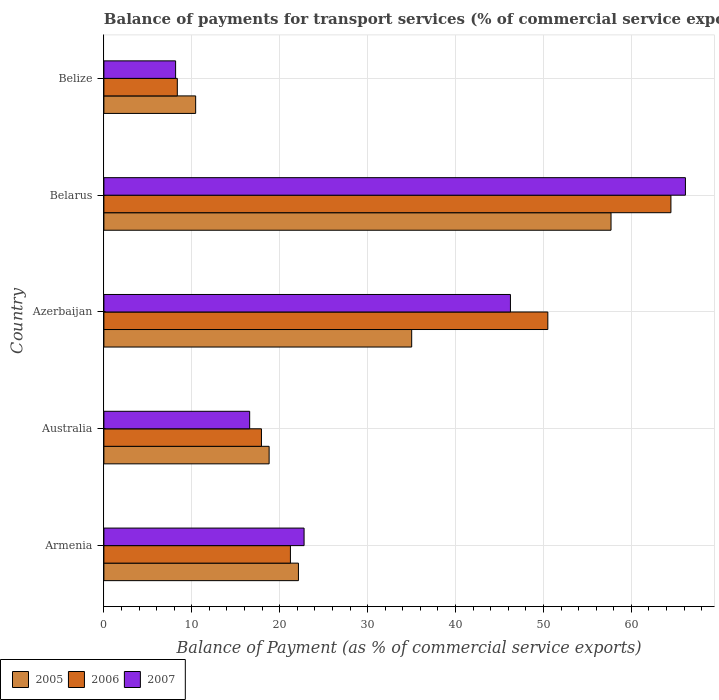How many different coloured bars are there?
Ensure brevity in your answer.  3. Are the number of bars on each tick of the Y-axis equal?
Offer a terse response. Yes. How many bars are there on the 2nd tick from the top?
Ensure brevity in your answer.  3. What is the label of the 2nd group of bars from the top?
Offer a terse response. Belarus. In how many cases, is the number of bars for a given country not equal to the number of legend labels?
Ensure brevity in your answer.  0. What is the balance of payments for transport services in 2005 in Azerbaijan?
Your answer should be compact. 35.01. Across all countries, what is the maximum balance of payments for transport services in 2007?
Make the answer very short. 66.15. Across all countries, what is the minimum balance of payments for transport services in 2006?
Provide a succinct answer. 8.35. In which country was the balance of payments for transport services in 2006 maximum?
Offer a terse response. Belarus. In which country was the balance of payments for transport services in 2007 minimum?
Provide a succinct answer. Belize. What is the total balance of payments for transport services in 2007 in the graph?
Your answer should be compact. 159.92. What is the difference between the balance of payments for transport services in 2007 in Armenia and that in Belize?
Provide a short and direct response. 14.61. What is the difference between the balance of payments for transport services in 2005 in Belarus and the balance of payments for transport services in 2007 in Armenia?
Offer a very short reply. 34.92. What is the average balance of payments for transport services in 2005 per country?
Your answer should be compact. 28.81. What is the difference between the balance of payments for transport services in 2007 and balance of payments for transport services in 2005 in Azerbaijan?
Your answer should be compact. 11.23. What is the ratio of the balance of payments for transport services in 2007 in Armenia to that in Azerbaijan?
Your response must be concise. 0.49. Is the balance of payments for transport services in 2006 in Australia less than that in Belize?
Provide a short and direct response. No. What is the difference between the highest and the second highest balance of payments for transport services in 2007?
Your answer should be compact. 19.91. What is the difference between the highest and the lowest balance of payments for transport services in 2007?
Ensure brevity in your answer.  58. In how many countries, is the balance of payments for transport services in 2006 greater than the average balance of payments for transport services in 2006 taken over all countries?
Provide a succinct answer. 2. What does the 3rd bar from the bottom in Azerbaijan represents?
Ensure brevity in your answer.  2007. Are all the bars in the graph horizontal?
Your answer should be very brief. Yes. How many countries are there in the graph?
Offer a very short reply. 5. What is the difference between two consecutive major ticks on the X-axis?
Provide a short and direct response. 10. Are the values on the major ticks of X-axis written in scientific E-notation?
Give a very brief answer. No. Does the graph contain any zero values?
Offer a very short reply. No. Does the graph contain grids?
Keep it short and to the point. Yes. Where does the legend appear in the graph?
Provide a succinct answer. Bottom left. How are the legend labels stacked?
Offer a terse response. Horizontal. What is the title of the graph?
Offer a very short reply. Balance of payments for transport services (% of commercial service exports). What is the label or title of the X-axis?
Provide a succinct answer. Balance of Payment (as % of commercial service exports). What is the Balance of Payment (as % of commercial service exports) in 2005 in Armenia?
Your response must be concise. 22.13. What is the Balance of Payment (as % of commercial service exports) in 2006 in Armenia?
Offer a very short reply. 21.22. What is the Balance of Payment (as % of commercial service exports) in 2007 in Armenia?
Provide a succinct answer. 22.77. What is the Balance of Payment (as % of commercial service exports) of 2005 in Australia?
Keep it short and to the point. 18.8. What is the Balance of Payment (as % of commercial service exports) in 2006 in Australia?
Provide a short and direct response. 17.92. What is the Balance of Payment (as % of commercial service exports) of 2007 in Australia?
Offer a terse response. 16.58. What is the Balance of Payment (as % of commercial service exports) of 2005 in Azerbaijan?
Keep it short and to the point. 35.01. What is the Balance of Payment (as % of commercial service exports) in 2006 in Azerbaijan?
Provide a succinct answer. 50.5. What is the Balance of Payment (as % of commercial service exports) of 2007 in Azerbaijan?
Your answer should be very brief. 46.25. What is the Balance of Payment (as % of commercial service exports) in 2005 in Belarus?
Ensure brevity in your answer.  57.69. What is the Balance of Payment (as % of commercial service exports) of 2006 in Belarus?
Provide a succinct answer. 64.51. What is the Balance of Payment (as % of commercial service exports) in 2007 in Belarus?
Ensure brevity in your answer.  66.15. What is the Balance of Payment (as % of commercial service exports) of 2005 in Belize?
Provide a succinct answer. 10.44. What is the Balance of Payment (as % of commercial service exports) of 2006 in Belize?
Provide a short and direct response. 8.35. What is the Balance of Payment (as % of commercial service exports) in 2007 in Belize?
Ensure brevity in your answer.  8.16. Across all countries, what is the maximum Balance of Payment (as % of commercial service exports) of 2005?
Provide a succinct answer. 57.69. Across all countries, what is the maximum Balance of Payment (as % of commercial service exports) in 2006?
Offer a terse response. 64.51. Across all countries, what is the maximum Balance of Payment (as % of commercial service exports) in 2007?
Keep it short and to the point. 66.15. Across all countries, what is the minimum Balance of Payment (as % of commercial service exports) of 2005?
Offer a very short reply. 10.44. Across all countries, what is the minimum Balance of Payment (as % of commercial service exports) in 2006?
Your answer should be compact. 8.35. Across all countries, what is the minimum Balance of Payment (as % of commercial service exports) in 2007?
Your response must be concise. 8.16. What is the total Balance of Payment (as % of commercial service exports) in 2005 in the graph?
Your answer should be compact. 144.07. What is the total Balance of Payment (as % of commercial service exports) in 2006 in the graph?
Offer a very short reply. 162.5. What is the total Balance of Payment (as % of commercial service exports) in 2007 in the graph?
Provide a succinct answer. 159.92. What is the difference between the Balance of Payment (as % of commercial service exports) in 2005 in Armenia and that in Australia?
Make the answer very short. 3.33. What is the difference between the Balance of Payment (as % of commercial service exports) in 2006 in Armenia and that in Australia?
Your response must be concise. 3.3. What is the difference between the Balance of Payment (as % of commercial service exports) of 2007 in Armenia and that in Australia?
Your response must be concise. 6.19. What is the difference between the Balance of Payment (as % of commercial service exports) of 2005 in Armenia and that in Azerbaijan?
Offer a very short reply. -12.88. What is the difference between the Balance of Payment (as % of commercial service exports) in 2006 in Armenia and that in Azerbaijan?
Your response must be concise. -29.28. What is the difference between the Balance of Payment (as % of commercial service exports) of 2007 in Armenia and that in Azerbaijan?
Provide a succinct answer. -23.48. What is the difference between the Balance of Payment (as % of commercial service exports) in 2005 in Armenia and that in Belarus?
Ensure brevity in your answer.  -35.56. What is the difference between the Balance of Payment (as % of commercial service exports) in 2006 in Armenia and that in Belarus?
Give a very brief answer. -43.29. What is the difference between the Balance of Payment (as % of commercial service exports) of 2007 in Armenia and that in Belarus?
Your answer should be compact. -43.38. What is the difference between the Balance of Payment (as % of commercial service exports) of 2005 in Armenia and that in Belize?
Give a very brief answer. 11.69. What is the difference between the Balance of Payment (as % of commercial service exports) in 2006 in Armenia and that in Belize?
Make the answer very short. 12.87. What is the difference between the Balance of Payment (as % of commercial service exports) of 2007 in Armenia and that in Belize?
Your response must be concise. 14.61. What is the difference between the Balance of Payment (as % of commercial service exports) in 2005 in Australia and that in Azerbaijan?
Provide a short and direct response. -16.22. What is the difference between the Balance of Payment (as % of commercial service exports) of 2006 in Australia and that in Azerbaijan?
Provide a succinct answer. -32.58. What is the difference between the Balance of Payment (as % of commercial service exports) in 2007 in Australia and that in Azerbaijan?
Your answer should be very brief. -29.66. What is the difference between the Balance of Payment (as % of commercial service exports) of 2005 in Australia and that in Belarus?
Offer a very short reply. -38.89. What is the difference between the Balance of Payment (as % of commercial service exports) in 2006 in Australia and that in Belarus?
Provide a short and direct response. -46.58. What is the difference between the Balance of Payment (as % of commercial service exports) of 2007 in Australia and that in Belarus?
Your answer should be compact. -49.57. What is the difference between the Balance of Payment (as % of commercial service exports) in 2005 in Australia and that in Belize?
Offer a terse response. 8.36. What is the difference between the Balance of Payment (as % of commercial service exports) of 2006 in Australia and that in Belize?
Your answer should be compact. 9.57. What is the difference between the Balance of Payment (as % of commercial service exports) in 2007 in Australia and that in Belize?
Your answer should be very brief. 8.43. What is the difference between the Balance of Payment (as % of commercial service exports) in 2005 in Azerbaijan and that in Belarus?
Your answer should be very brief. -22.68. What is the difference between the Balance of Payment (as % of commercial service exports) in 2006 in Azerbaijan and that in Belarus?
Your answer should be very brief. -14. What is the difference between the Balance of Payment (as % of commercial service exports) of 2007 in Azerbaijan and that in Belarus?
Give a very brief answer. -19.91. What is the difference between the Balance of Payment (as % of commercial service exports) of 2005 in Azerbaijan and that in Belize?
Offer a very short reply. 24.58. What is the difference between the Balance of Payment (as % of commercial service exports) of 2006 in Azerbaijan and that in Belize?
Your answer should be compact. 42.15. What is the difference between the Balance of Payment (as % of commercial service exports) of 2007 in Azerbaijan and that in Belize?
Make the answer very short. 38.09. What is the difference between the Balance of Payment (as % of commercial service exports) in 2005 in Belarus and that in Belize?
Ensure brevity in your answer.  47.25. What is the difference between the Balance of Payment (as % of commercial service exports) in 2006 in Belarus and that in Belize?
Offer a terse response. 56.15. What is the difference between the Balance of Payment (as % of commercial service exports) in 2007 in Belarus and that in Belize?
Offer a very short reply. 58. What is the difference between the Balance of Payment (as % of commercial service exports) of 2005 in Armenia and the Balance of Payment (as % of commercial service exports) of 2006 in Australia?
Give a very brief answer. 4.21. What is the difference between the Balance of Payment (as % of commercial service exports) in 2005 in Armenia and the Balance of Payment (as % of commercial service exports) in 2007 in Australia?
Offer a terse response. 5.55. What is the difference between the Balance of Payment (as % of commercial service exports) in 2006 in Armenia and the Balance of Payment (as % of commercial service exports) in 2007 in Australia?
Give a very brief answer. 4.64. What is the difference between the Balance of Payment (as % of commercial service exports) of 2005 in Armenia and the Balance of Payment (as % of commercial service exports) of 2006 in Azerbaijan?
Ensure brevity in your answer.  -28.37. What is the difference between the Balance of Payment (as % of commercial service exports) of 2005 in Armenia and the Balance of Payment (as % of commercial service exports) of 2007 in Azerbaijan?
Give a very brief answer. -24.12. What is the difference between the Balance of Payment (as % of commercial service exports) in 2006 in Armenia and the Balance of Payment (as % of commercial service exports) in 2007 in Azerbaijan?
Your answer should be very brief. -25.03. What is the difference between the Balance of Payment (as % of commercial service exports) of 2005 in Armenia and the Balance of Payment (as % of commercial service exports) of 2006 in Belarus?
Make the answer very short. -42.37. What is the difference between the Balance of Payment (as % of commercial service exports) of 2005 in Armenia and the Balance of Payment (as % of commercial service exports) of 2007 in Belarus?
Your answer should be very brief. -44.02. What is the difference between the Balance of Payment (as % of commercial service exports) of 2006 in Armenia and the Balance of Payment (as % of commercial service exports) of 2007 in Belarus?
Your answer should be compact. -44.93. What is the difference between the Balance of Payment (as % of commercial service exports) of 2005 in Armenia and the Balance of Payment (as % of commercial service exports) of 2006 in Belize?
Provide a succinct answer. 13.78. What is the difference between the Balance of Payment (as % of commercial service exports) of 2005 in Armenia and the Balance of Payment (as % of commercial service exports) of 2007 in Belize?
Give a very brief answer. 13.97. What is the difference between the Balance of Payment (as % of commercial service exports) of 2006 in Armenia and the Balance of Payment (as % of commercial service exports) of 2007 in Belize?
Make the answer very short. 13.06. What is the difference between the Balance of Payment (as % of commercial service exports) in 2005 in Australia and the Balance of Payment (as % of commercial service exports) in 2006 in Azerbaijan?
Give a very brief answer. -31.7. What is the difference between the Balance of Payment (as % of commercial service exports) of 2005 in Australia and the Balance of Payment (as % of commercial service exports) of 2007 in Azerbaijan?
Keep it short and to the point. -27.45. What is the difference between the Balance of Payment (as % of commercial service exports) of 2006 in Australia and the Balance of Payment (as % of commercial service exports) of 2007 in Azerbaijan?
Your response must be concise. -28.33. What is the difference between the Balance of Payment (as % of commercial service exports) in 2005 in Australia and the Balance of Payment (as % of commercial service exports) in 2006 in Belarus?
Your answer should be compact. -45.71. What is the difference between the Balance of Payment (as % of commercial service exports) in 2005 in Australia and the Balance of Payment (as % of commercial service exports) in 2007 in Belarus?
Give a very brief answer. -47.36. What is the difference between the Balance of Payment (as % of commercial service exports) of 2006 in Australia and the Balance of Payment (as % of commercial service exports) of 2007 in Belarus?
Your response must be concise. -48.23. What is the difference between the Balance of Payment (as % of commercial service exports) of 2005 in Australia and the Balance of Payment (as % of commercial service exports) of 2006 in Belize?
Your answer should be compact. 10.44. What is the difference between the Balance of Payment (as % of commercial service exports) of 2005 in Australia and the Balance of Payment (as % of commercial service exports) of 2007 in Belize?
Make the answer very short. 10.64. What is the difference between the Balance of Payment (as % of commercial service exports) of 2006 in Australia and the Balance of Payment (as % of commercial service exports) of 2007 in Belize?
Offer a very short reply. 9.76. What is the difference between the Balance of Payment (as % of commercial service exports) in 2005 in Azerbaijan and the Balance of Payment (as % of commercial service exports) in 2006 in Belarus?
Keep it short and to the point. -29.49. What is the difference between the Balance of Payment (as % of commercial service exports) of 2005 in Azerbaijan and the Balance of Payment (as % of commercial service exports) of 2007 in Belarus?
Your answer should be very brief. -31.14. What is the difference between the Balance of Payment (as % of commercial service exports) in 2006 in Azerbaijan and the Balance of Payment (as % of commercial service exports) in 2007 in Belarus?
Keep it short and to the point. -15.65. What is the difference between the Balance of Payment (as % of commercial service exports) of 2005 in Azerbaijan and the Balance of Payment (as % of commercial service exports) of 2006 in Belize?
Keep it short and to the point. 26.66. What is the difference between the Balance of Payment (as % of commercial service exports) in 2005 in Azerbaijan and the Balance of Payment (as % of commercial service exports) in 2007 in Belize?
Your answer should be compact. 26.86. What is the difference between the Balance of Payment (as % of commercial service exports) of 2006 in Azerbaijan and the Balance of Payment (as % of commercial service exports) of 2007 in Belize?
Offer a terse response. 42.34. What is the difference between the Balance of Payment (as % of commercial service exports) of 2005 in Belarus and the Balance of Payment (as % of commercial service exports) of 2006 in Belize?
Offer a very short reply. 49.34. What is the difference between the Balance of Payment (as % of commercial service exports) of 2005 in Belarus and the Balance of Payment (as % of commercial service exports) of 2007 in Belize?
Give a very brief answer. 49.53. What is the difference between the Balance of Payment (as % of commercial service exports) in 2006 in Belarus and the Balance of Payment (as % of commercial service exports) in 2007 in Belize?
Your response must be concise. 56.35. What is the average Balance of Payment (as % of commercial service exports) in 2005 per country?
Your response must be concise. 28.81. What is the average Balance of Payment (as % of commercial service exports) in 2006 per country?
Offer a very short reply. 32.5. What is the average Balance of Payment (as % of commercial service exports) of 2007 per country?
Your response must be concise. 31.98. What is the difference between the Balance of Payment (as % of commercial service exports) of 2005 and Balance of Payment (as % of commercial service exports) of 2006 in Armenia?
Make the answer very short. 0.91. What is the difference between the Balance of Payment (as % of commercial service exports) of 2005 and Balance of Payment (as % of commercial service exports) of 2007 in Armenia?
Give a very brief answer. -0.64. What is the difference between the Balance of Payment (as % of commercial service exports) of 2006 and Balance of Payment (as % of commercial service exports) of 2007 in Armenia?
Provide a succinct answer. -1.55. What is the difference between the Balance of Payment (as % of commercial service exports) in 2005 and Balance of Payment (as % of commercial service exports) in 2006 in Australia?
Offer a very short reply. 0.87. What is the difference between the Balance of Payment (as % of commercial service exports) of 2005 and Balance of Payment (as % of commercial service exports) of 2007 in Australia?
Keep it short and to the point. 2.21. What is the difference between the Balance of Payment (as % of commercial service exports) in 2006 and Balance of Payment (as % of commercial service exports) in 2007 in Australia?
Your answer should be compact. 1.34. What is the difference between the Balance of Payment (as % of commercial service exports) of 2005 and Balance of Payment (as % of commercial service exports) of 2006 in Azerbaijan?
Provide a short and direct response. -15.49. What is the difference between the Balance of Payment (as % of commercial service exports) in 2005 and Balance of Payment (as % of commercial service exports) in 2007 in Azerbaijan?
Provide a short and direct response. -11.23. What is the difference between the Balance of Payment (as % of commercial service exports) in 2006 and Balance of Payment (as % of commercial service exports) in 2007 in Azerbaijan?
Your answer should be compact. 4.25. What is the difference between the Balance of Payment (as % of commercial service exports) in 2005 and Balance of Payment (as % of commercial service exports) in 2006 in Belarus?
Offer a very short reply. -6.81. What is the difference between the Balance of Payment (as % of commercial service exports) of 2005 and Balance of Payment (as % of commercial service exports) of 2007 in Belarus?
Give a very brief answer. -8.46. What is the difference between the Balance of Payment (as % of commercial service exports) in 2006 and Balance of Payment (as % of commercial service exports) in 2007 in Belarus?
Your response must be concise. -1.65. What is the difference between the Balance of Payment (as % of commercial service exports) in 2005 and Balance of Payment (as % of commercial service exports) in 2006 in Belize?
Keep it short and to the point. 2.09. What is the difference between the Balance of Payment (as % of commercial service exports) of 2005 and Balance of Payment (as % of commercial service exports) of 2007 in Belize?
Provide a short and direct response. 2.28. What is the difference between the Balance of Payment (as % of commercial service exports) of 2006 and Balance of Payment (as % of commercial service exports) of 2007 in Belize?
Provide a succinct answer. 0.19. What is the ratio of the Balance of Payment (as % of commercial service exports) of 2005 in Armenia to that in Australia?
Offer a very short reply. 1.18. What is the ratio of the Balance of Payment (as % of commercial service exports) in 2006 in Armenia to that in Australia?
Offer a very short reply. 1.18. What is the ratio of the Balance of Payment (as % of commercial service exports) of 2007 in Armenia to that in Australia?
Give a very brief answer. 1.37. What is the ratio of the Balance of Payment (as % of commercial service exports) of 2005 in Armenia to that in Azerbaijan?
Your answer should be compact. 0.63. What is the ratio of the Balance of Payment (as % of commercial service exports) of 2006 in Armenia to that in Azerbaijan?
Your answer should be very brief. 0.42. What is the ratio of the Balance of Payment (as % of commercial service exports) in 2007 in Armenia to that in Azerbaijan?
Provide a succinct answer. 0.49. What is the ratio of the Balance of Payment (as % of commercial service exports) of 2005 in Armenia to that in Belarus?
Make the answer very short. 0.38. What is the ratio of the Balance of Payment (as % of commercial service exports) of 2006 in Armenia to that in Belarus?
Offer a very short reply. 0.33. What is the ratio of the Balance of Payment (as % of commercial service exports) of 2007 in Armenia to that in Belarus?
Your answer should be compact. 0.34. What is the ratio of the Balance of Payment (as % of commercial service exports) in 2005 in Armenia to that in Belize?
Offer a very short reply. 2.12. What is the ratio of the Balance of Payment (as % of commercial service exports) of 2006 in Armenia to that in Belize?
Your response must be concise. 2.54. What is the ratio of the Balance of Payment (as % of commercial service exports) in 2007 in Armenia to that in Belize?
Your answer should be compact. 2.79. What is the ratio of the Balance of Payment (as % of commercial service exports) of 2005 in Australia to that in Azerbaijan?
Offer a terse response. 0.54. What is the ratio of the Balance of Payment (as % of commercial service exports) of 2006 in Australia to that in Azerbaijan?
Your response must be concise. 0.35. What is the ratio of the Balance of Payment (as % of commercial service exports) of 2007 in Australia to that in Azerbaijan?
Your answer should be very brief. 0.36. What is the ratio of the Balance of Payment (as % of commercial service exports) of 2005 in Australia to that in Belarus?
Your response must be concise. 0.33. What is the ratio of the Balance of Payment (as % of commercial service exports) in 2006 in Australia to that in Belarus?
Provide a short and direct response. 0.28. What is the ratio of the Balance of Payment (as % of commercial service exports) in 2007 in Australia to that in Belarus?
Ensure brevity in your answer.  0.25. What is the ratio of the Balance of Payment (as % of commercial service exports) of 2005 in Australia to that in Belize?
Offer a very short reply. 1.8. What is the ratio of the Balance of Payment (as % of commercial service exports) of 2006 in Australia to that in Belize?
Offer a terse response. 2.15. What is the ratio of the Balance of Payment (as % of commercial service exports) of 2007 in Australia to that in Belize?
Provide a succinct answer. 2.03. What is the ratio of the Balance of Payment (as % of commercial service exports) in 2005 in Azerbaijan to that in Belarus?
Provide a succinct answer. 0.61. What is the ratio of the Balance of Payment (as % of commercial service exports) of 2006 in Azerbaijan to that in Belarus?
Make the answer very short. 0.78. What is the ratio of the Balance of Payment (as % of commercial service exports) in 2007 in Azerbaijan to that in Belarus?
Your answer should be compact. 0.7. What is the ratio of the Balance of Payment (as % of commercial service exports) in 2005 in Azerbaijan to that in Belize?
Keep it short and to the point. 3.35. What is the ratio of the Balance of Payment (as % of commercial service exports) in 2006 in Azerbaijan to that in Belize?
Your answer should be compact. 6.05. What is the ratio of the Balance of Payment (as % of commercial service exports) in 2007 in Azerbaijan to that in Belize?
Give a very brief answer. 5.67. What is the ratio of the Balance of Payment (as % of commercial service exports) in 2005 in Belarus to that in Belize?
Offer a very short reply. 5.53. What is the ratio of the Balance of Payment (as % of commercial service exports) in 2006 in Belarus to that in Belize?
Your answer should be compact. 7.72. What is the ratio of the Balance of Payment (as % of commercial service exports) in 2007 in Belarus to that in Belize?
Offer a terse response. 8.11. What is the difference between the highest and the second highest Balance of Payment (as % of commercial service exports) of 2005?
Give a very brief answer. 22.68. What is the difference between the highest and the second highest Balance of Payment (as % of commercial service exports) in 2006?
Your response must be concise. 14. What is the difference between the highest and the second highest Balance of Payment (as % of commercial service exports) in 2007?
Provide a succinct answer. 19.91. What is the difference between the highest and the lowest Balance of Payment (as % of commercial service exports) in 2005?
Provide a short and direct response. 47.25. What is the difference between the highest and the lowest Balance of Payment (as % of commercial service exports) in 2006?
Offer a very short reply. 56.15. What is the difference between the highest and the lowest Balance of Payment (as % of commercial service exports) in 2007?
Provide a short and direct response. 58. 